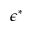Convert formula to latex. <formula><loc_0><loc_0><loc_500><loc_500>\epsilon ^ { * }</formula> 